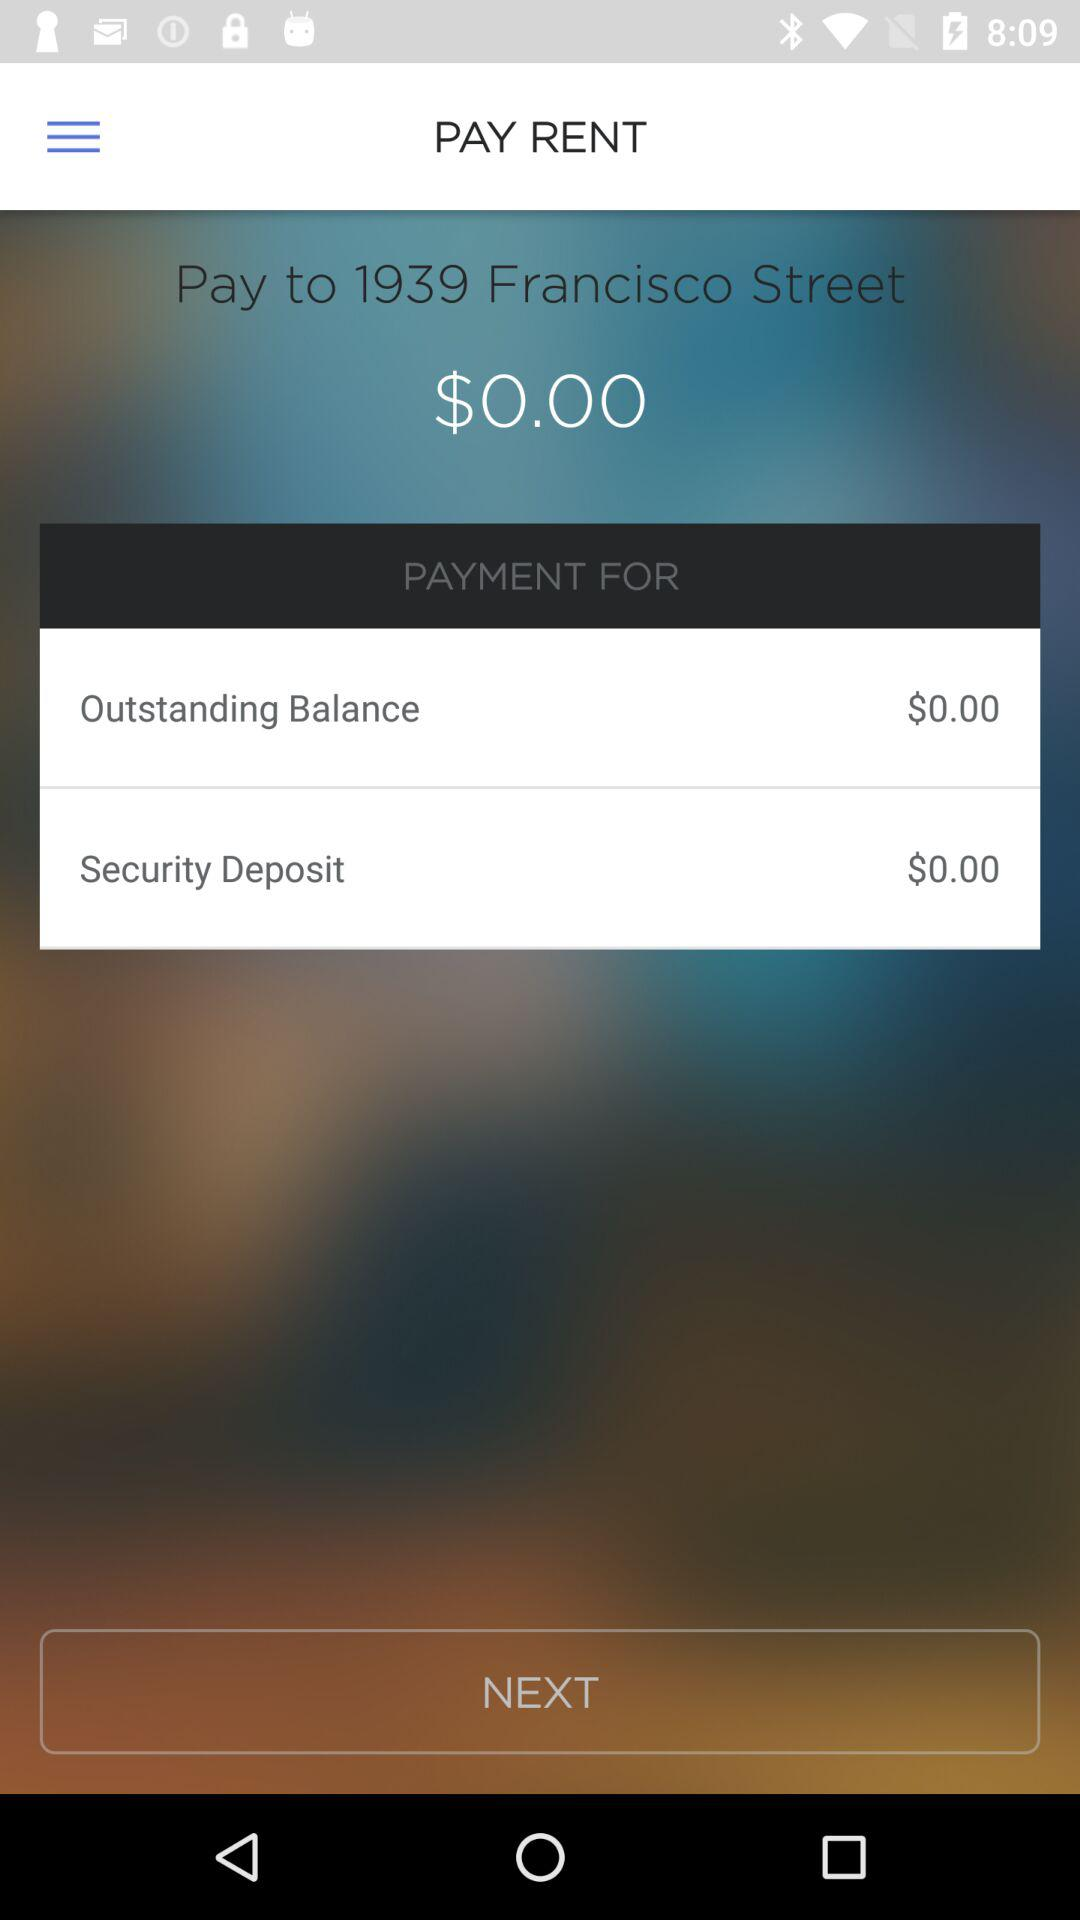How much is the outstanding balance?
Answer the question using a single word or phrase. $0.00 